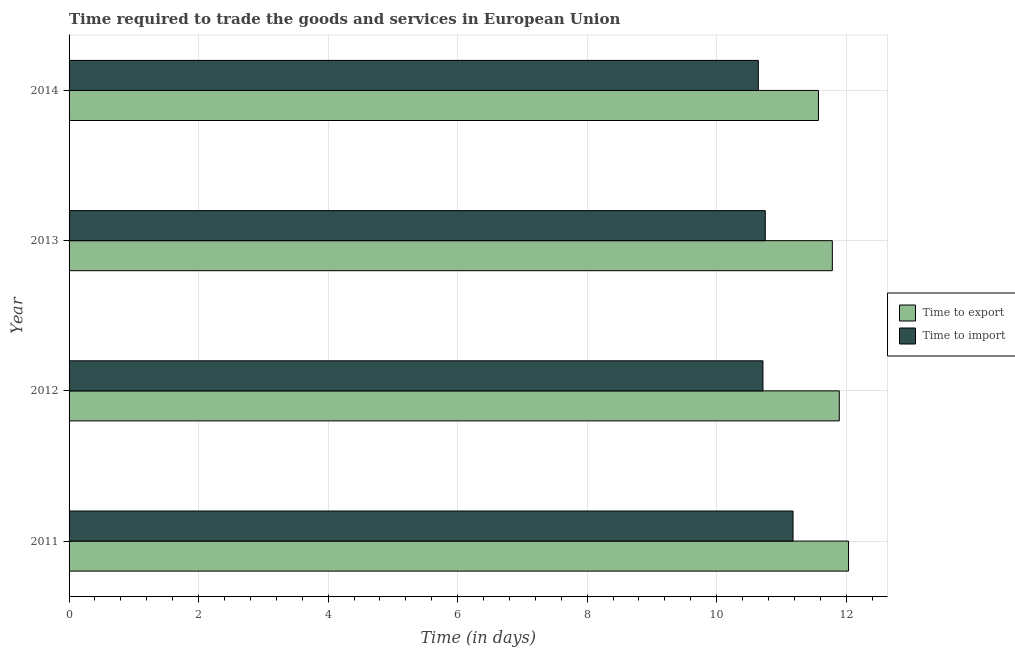How many groups of bars are there?
Ensure brevity in your answer.  4. Are the number of bars per tick equal to the number of legend labels?
Ensure brevity in your answer.  Yes. Are the number of bars on each tick of the Y-axis equal?
Offer a very short reply. Yes. In how many cases, is the number of bars for a given year not equal to the number of legend labels?
Offer a very short reply. 0. What is the time to import in 2012?
Your answer should be compact. 10.71. Across all years, what is the maximum time to import?
Your response must be concise. 11.18. Across all years, what is the minimum time to import?
Give a very brief answer. 10.64. In which year was the time to import maximum?
Give a very brief answer. 2011. In which year was the time to import minimum?
Give a very brief answer. 2014. What is the total time to export in the graph?
Ensure brevity in your answer.  47.29. What is the difference between the time to export in 2012 and that in 2013?
Provide a succinct answer. 0.11. What is the difference between the time to import in 2014 and the time to export in 2013?
Provide a short and direct response. -1.14. What is the average time to import per year?
Your answer should be very brief. 10.82. In the year 2014, what is the difference between the time to import and time to export?
Offer a terse response. -0.93. Is the difference between the time to export in 2012 and 2013 greater than the difference between the time to import in 2012 and 2013?
Give a very brief answer. Yes. What is the difference between the highest and the second highest time to import?
Ensure brevity in your answer.  0.43. What is the difference between the highest and the lowest time to export?
Your response must be concise. 0.46. In how many years, is the time to import greater than the average time to import taken over all years?
Offer a terse response. 1. Is the sum of the time to export in 2013 and 2014 greater than the maximum time to import across all years?
Offer a very short reply. Yes. What does the 2nd bar from the top in 2013 represents?
Make the answer very short. Time to export. What does the 2nd bar from the bottom in 2012 represents?
Make the answer very short. Time to import. Are all the bars in the graph horizontal?
Offer a very short reply. Yes. Where does the legend appear in the graph?
Make the answer very short. Center right. How are the legend labels stacked?
Your response must be concise. Vertical. What is the title of the graph?
Ensure brevity in your answer.  Time required to trade the goods and services in European Union. What is the label or title of the X-axis?
Provide a succinct answer. Time (in days). What is the label or title of the Y-axis?
Keep it short and to the point. Year. What is the Time (in days) in Time to export in 2011?
Offer a very short reply. 12.04. What is the Time (in days) in Time to import in 2011?
Keep it short and to the point. 11.18. What is the Time (in days) in Time to export in 2012?
Offer a terse response. 11.89. What is the Time (in days) of Time to import in 2012?
Keep it short and to the point. 10.71. What is the Time (in days) in Time to export in 2013?
Your answer should be compact. 11.79. What is the Time (in days) of Time to import in 2013?
Offer a terse response. 10.75. What is the Time (in days) of Time to export in 2014?
Provide a short and direct response. 11.57. What is the Time (in days) in Time to import in 2014?
Your response must be concise. 10.64. Across all years, what is the maximum Time (in days) in Time to export?
Your response must be concise. 12.04. Across all years, what is the maximum Time (in days) of Time to import?
Your answer should be compact. 11.18. Across all years, what is the minimum Time (in days) in Time to export?
Keep it short and to the point. 11.57. Across all years, what is the minimum Time (in days) of Time to import?
Your answer should be compact. 10.64. What is the total Time (in days) in Time to export in the graph?
Offer a terse response. 47.29. What is the total Time (in days) of Time to import in the graph?
Your answer should be compact. 43.29. What is the difference between the Time (in days) of Time to export in 2011 and that in 2012?
Offer a very short reply. 0.14. What is the difference between the Time (in days) in Time to import in 2011 and that in 2012?
Your response must be concise. 0.46. What is the difference between the Time (in days) of Time to import in 2011 and that in 2013?
Offer a very short reply. 0.43. What is the difference between the Time (in days) of Time to export in 2011 and that in 2014?
Make the answer very short. 0.46. What is the difference between the Time (in days) of Time to import in 2011 and that in 2014?
Offer a very short reply. 0.54. What is the difference between the Time (in days) in Time to export in 2012 and that in 2013?
Give a very brief answer. 0.11. What is the difference between the Time (in days) in Time to import in 2012 and that in 2013?
Give a very brief answer. -0.04. What is the difference between the Time (in days) in Time to export in 2012 and that in 2014?
Give a very brief answer. 0.32. What is the difference between the Time (in days) in Time to import in 2012 and that in 2014?
Your answer should be very brief. 0.07. What is the difference between the Time (in days) of Time to export in 2013 and that in 2014?
Give a very brief answer. 0.21. What is the difference between the Time (in days) in Time to import in 2013 and that in 2014?
Make the answer very short. 0.11. What is the difference between the Time (in days) in Time to export in 2011 and the Time (in days) in Time to import in 2012?
Provide a short and direct response. 1.32. What is the difference between the Time (in days) in Time to export in 2011 and the Time (in days) in Time to import in 2014?
Keep it short and to the point. 1.39. What is the difference between the Time (in days) in Time to export in 2012 and the Time (in days) in Time to import in 2014?
Your response must be concise. 1.25. What is the average Time (in days) of Time to export per year?
Provide a short and direct response. 11.82. What is the average Time (in days) of Time to import per year?
Offer a very short reply. 10.82. In the year 2012, what is the difference between the Time (in days) of Time to export and Time (in days) of Time to import?
Provide a short and direct response. 1.18. In the year 2013, what is the difference between the Time (in days) of Time to export and Time (in days) of Time to import?
Your answer should be compact. 1.04. What is the ratio of the Time (in days) of Time to export in 2011 to that in 2012?
Provide a short and direct response. 1.01. What is the ratio of the Time (in days) in Time to import in 2011 to that in 2012?
Give a very brief answer. 1.04. What is the ratio of the Time (in days) in Time to export in 2011 to that in 2013?
Give a very brief answer. 1.02. What is the ratio of the Time (in days) in Time to import in 2011 to that in 2013?
Your answer should be compact. 1.04. What is the ratio of the Time (in days) in Time to export in 2011 to that in 2014?
Your response must be concise. 1.04. What is the ratio of the Time (in days) of Time to import in 2011 to that in 2014?
Offer a very short reply. 1.05. What is the ratio of the Time (in days) of Time to export in 2012 to that in 2013?
Make the answer very short. 1.01. What is the ratio of the Time (in days) of Time to export in 2012 to that in 2014?
Give a very brief answer. 1.03. What is the ratio of the Time (in days) in Time to export in 2013 to that in 2014?
Make the answer very short. 1.02. What is the ratio of the Time (in days) in Time to import in 2013 to that in 2014?
Your response must be concise. 1.01. What is the difference between the highest and the second highest Time (in days) in Time to export?
Your response must be concise. 0.14. What is the difference between the highest and the second highest Time (in days) of Time to import?
Provide a succinct answer. 0.43. What is the difference between the highest and the lowest Time (in days) of Time to export?
Offer a very short reply. 0.46. What is the difference between the highest and the lowest Time (in days) in Time to import?
Your answer should be compact. 0.54. 